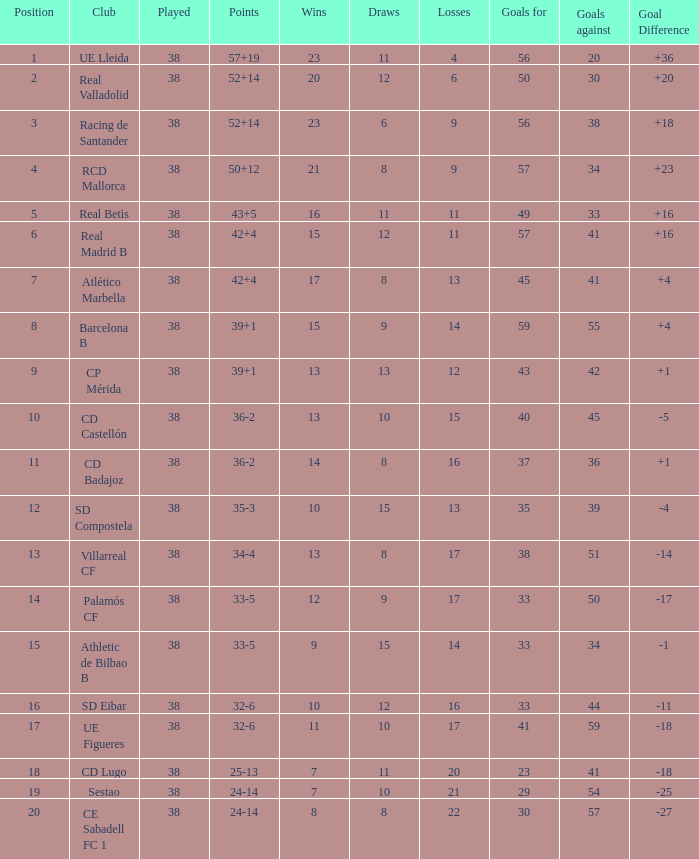What is the highest number of loss with a 7 position and more than 45 goals? None. 